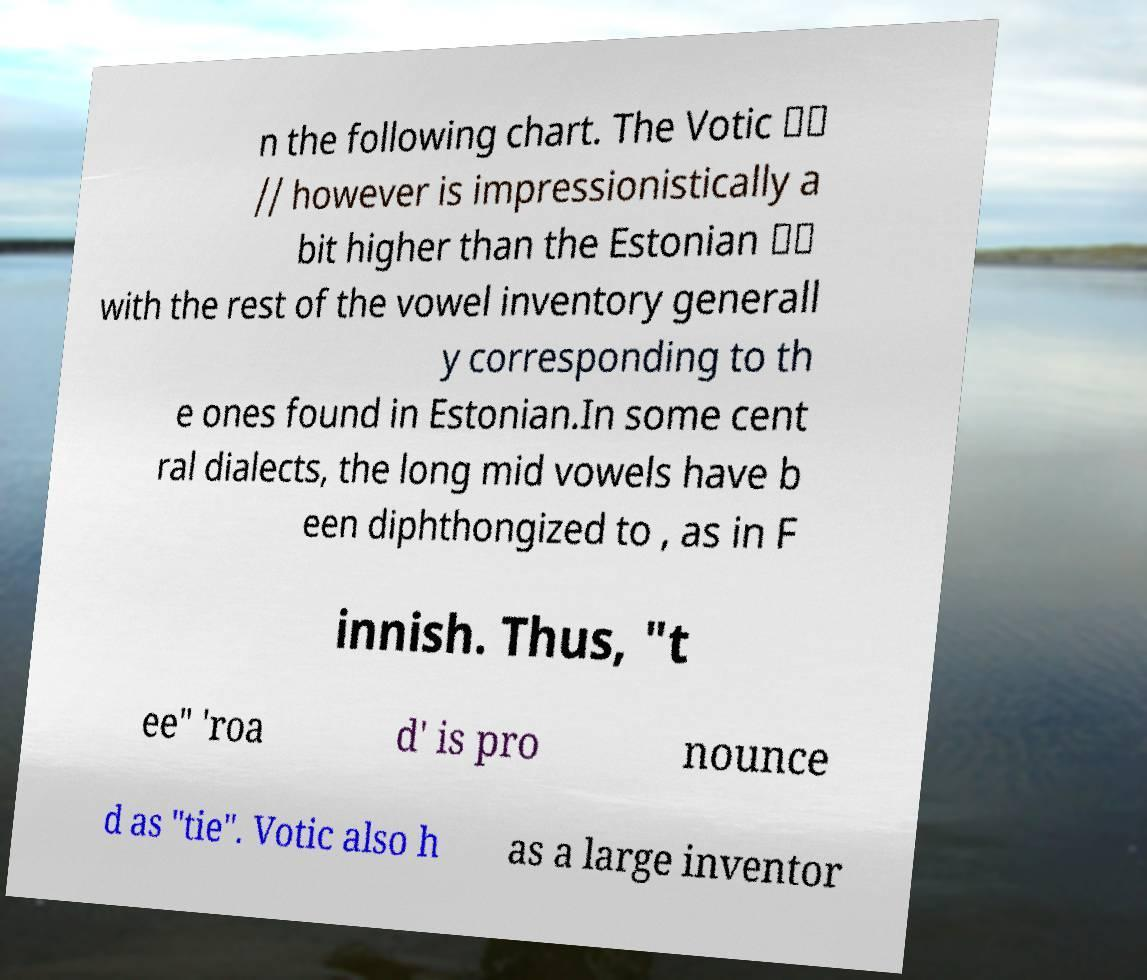I need the written content from this picture converted into text. Can you do that? n the following chart. The Votic ⟨⟩ // however is impressionistically a bit higher than the Estonian ⟨⟩ with the rest of the vowel inventory generall y corresponding to th e ones found in Estonian.In some cent ral dialects, the long mid vowels have b een diphthongized to , as in F innish. Thus, "t ee" 'roa d' is pro nounce d as "tie". Votic also h as a large inventor 